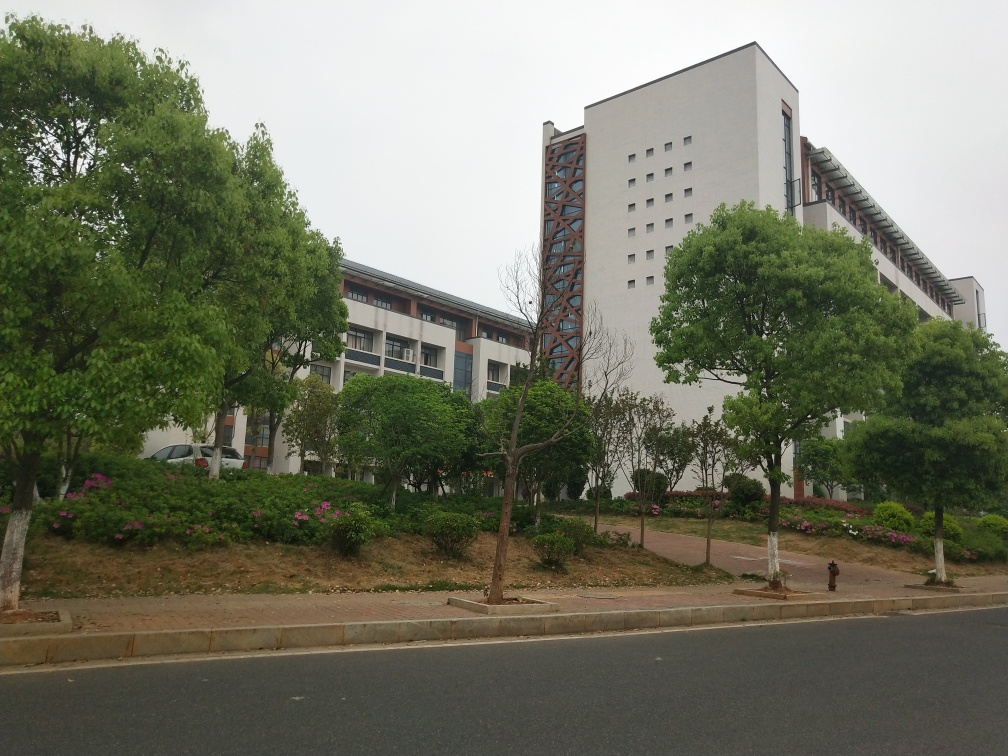What type of buildings can be seen in this image? The image shows residential or possibly educational buildings, characterized by multiple stories and rows of windows. The tallest building appears to have a unique design with external features resembling braces or supports. 